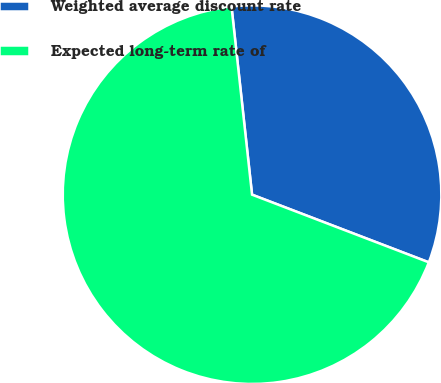Convert chart. <chart><loc_0><loc_0><loc_500><loc_500><pie_chart><fcel>Weighted average discount rate<fcel>Expected long-term rate of<nl><fcel>32.55%<fcel>67.45%<nl></chart> 